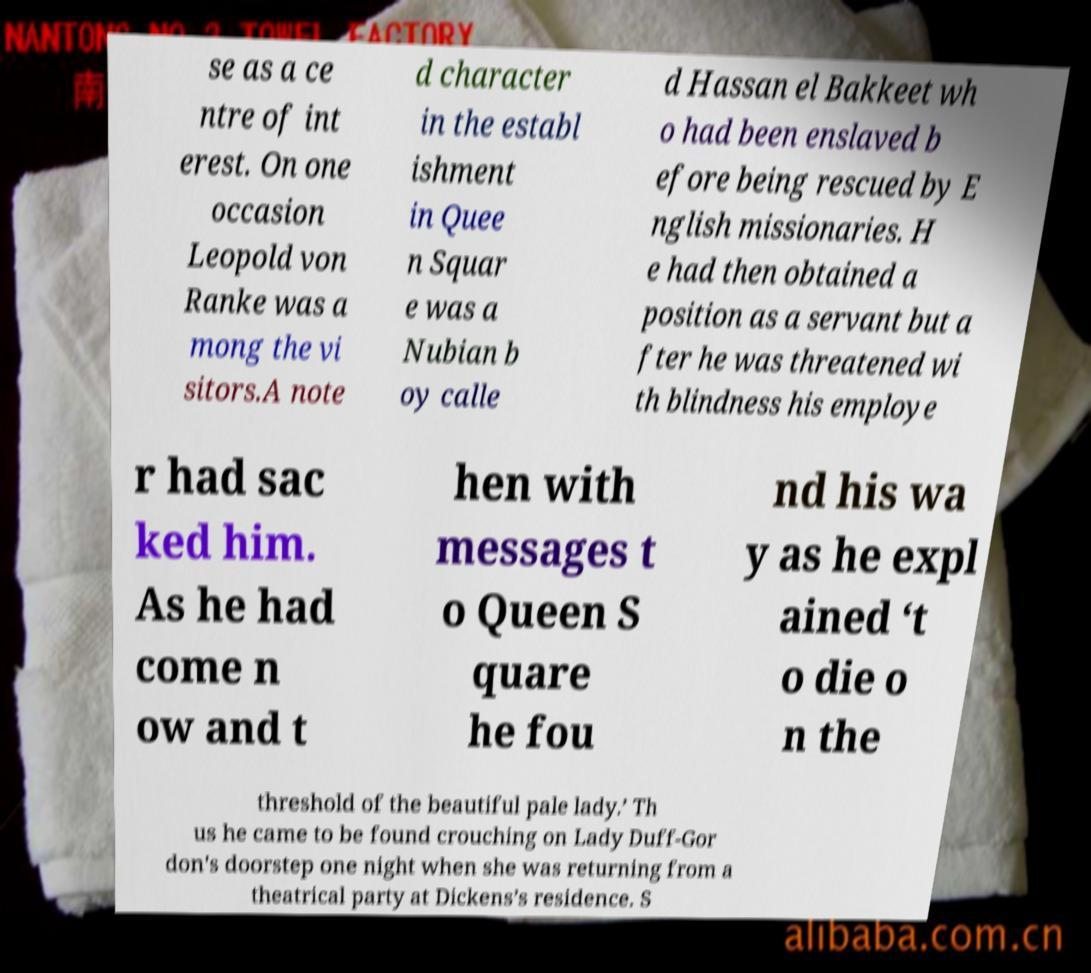Could you assist in decoding the text presented in this image and type it out clearly? se as a ce ntre of int erest. On one occasion Leopold von Ranke was a mong the vi sitors.A note d character in the establ ishment in Quee n Squar e was a Nubian b oy calle d Hassan el Bakkeet wh o had been enslaved b efore being rescued by E nglish missionaries. H e had then obtained a position as a servant but a fter he was threatened wi th blindness his employe r had sac ked him. As he had come n ow and t hen with messages t o Queen S quare he fou nd his wa y as he expl ained ‘t o die o n the threshold of the beautiful pale lady.’ Th us he came to be found crouching on Lady Duff-Gor don's doorstep one night when she was returning from a theatrical party at Dickens’s residence. S 